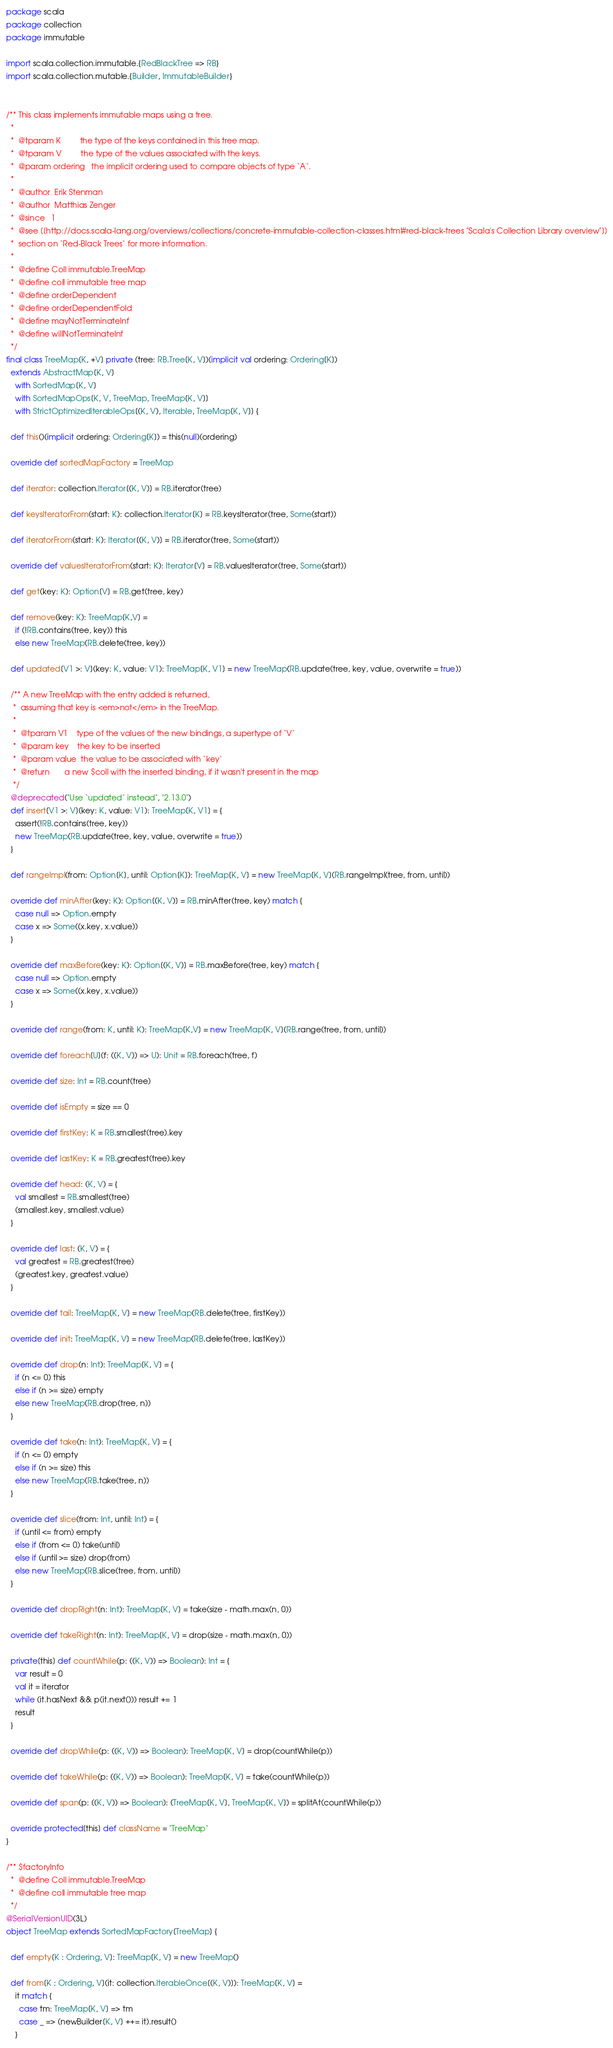<code> <loc_0><loc_0><loc_500><loc_500><_Scala_>package scala
package collection
package immutable

import scala.collection.immutable.{RedBlackTree => RB}
import scala.collection.mutable.{Builder, ImmutableBuilder}


/** This class implements immutable maps using a tree.
  *
  *  @tparam K         the type of the keys contained in this tree map.
  *  @tparam V         the type of the values associated with the keys.
  *  @param ordering   the implicit ordering used to compare objects of type `A`.
  *
  *  @author  Erik Stenman
  *  @author  Matthias Zenger
  *  @since   1
  *  @see [[http://docs.scala-lang.org/overviews/collections/concrete-immutable-collection-classes.html#red-black-trees "Scala's Collection Library overview"]]
  *  section on `Red-Black Trees` for more information.
  *
  *  @define Coll immutable.TreeMap
  *  @define coll immutable tree map
  *  @define orderDependent
  *  @define orderDependentFold
  *  @define mayNotTerminateInf
  *  @define willNotTerminateInf
  */
final class TreeMap[K, +V] private (tree: RB.Tree[K, V])(implicit val ordering: Ordering[K])
  extends AbstractMap[K, V]
    with SortedMap[K, V]
    with SortedMapOps[K, V, TreeMap, TreeMap[K, V]]
    with StrictOptimizedIterableOps[(K, V), Iterable, TreeMap[K, V]] {

  def this()(implicit ordering: Ordering[K]) = this(null)(ordering)

  override def sortedMapFactory = TreeMap

  def iterator: collection.Iterator[(K, V)] = RB.iterator(tree)

  def keysIteratorFrom(start: K): collection.Iterator[K] = RB.keysIterator(tree, Some(start))

  def iteratorFrom(start: K): Iterator[(K, V)] = RB.iterator(tree, Some(start))

  override def valuesIteratorFrom(start: K): Iterator[V] = RB.valuesIterator(tree, Some(start))

  def get(key: K): Option[V] = RB.get(tree, key)

  def remove(key: K): TreeMap[K,V] =
    if (!RB.contains(tree, key)) this
    else new TreeMap(RB.delete(tree, key))

  def updated[V1 >: V](key: K, value: V1): TreeMap[K, V1] = new TreeMap(RB.update(tree, key, value, overwrite = true))

  /** A new TreeMap with the entry added is returned,
   *  assuming that key is <em>not</em> in the TreeMap.
   *
   *  @tparam V1    type of the values of the new bindings, a supertype of `V`
   *  @param key    the key to be inserted
   *  @param value  the value to be associated with `key`
   *  @return       a new $coll with the inserted binding, if it wasn't present in the map
   */
  @deprecated("Use `updated` instead", "2.13.0")
  def insert[V1 >: V](key: K, value: V1): TreeMap[K, V1] = {
    assert(!RB.contains(tree, key))
    new TreeMap(RB.update(tree, key, value, overwrite = true))
  }

  def rangeImpl(from: Option[K], until: Option[K]): TreeMap[K, V] = new TreeMap[K, V](RB.rangeImpl(tree, from, until))

  override def minAfter(key: K): Option[(K, V)] = RB.minAfter(tree, key) match {
    case null => Option.empty
    case x => Some((x.key, x.value))
  }

  override def maxBefore(key: K): Option[(K, V)] = RB.maxBefore(tree, key) match {
    case null => Option.empty
    case x => Some((x.key, x.value))
  }

  override def range(from: K, until: K): TreeMap[K,V] = new TreeMap[K, V](RB.range(tree, from, until))

  override def foreach[U](f: ((K, V)) => U): Unit = RB.foreach(tree, f)

  override def size: Int = RB.count(tree)

  override def isEmpty = size == 0

  override def firstKey: K = RB.smallest(tree).key

  override def lastKey: K = RB.greatest(tree).key

  override def head: (K, V) = {
    val smallest = RB.smallest(tree)
    (smallest.key, smallest.value)
  }

  override def last: (K, V) = {
    val greatest = RB.greatest(tree)
    (greatest.key, greatest.value)
  }

  override def tail: TreeMap[K, V] = new TreeMap(RB.delete(tree, firstKey))

  override def init: TreeMap[K, V] = new TreeMap(RB.delete(tree, lastKey))

  override def drop(n: Int): TreeMap[K, V] = {
    if (n <= 0) this
    else if (n >= size) empty
    else new TreeMap(RB.drop(tree, n))
  }

  override def take(n: Int): TreeMap[K, V] = {
    if (n <= 0) empty
    else if (n >= size) this
    else new TreeMap(RB.take(tree, n))
  }

  override def slice(from: Int, until: Int) = {
    if (until <= from) empty
    else if (from <= 0) take(until)
    else if (until >= size) drop(from)
    else new TreeMap(RB.slice(tree, from, until))
  }

  override def dropRight(n: Int): TreeMap[K, V] = take(size - math.max(n, 0))

  override def takeRight(n: Int): TreeMap[K, V] = drop(size - math.max(n, 0))

  private[this] def countWhile(p: ((K, V)) => Boolean): Int = {
    var result = 0
    val it = iterator
    while (it.hasNext && p(it.next())) result += 1
    result
  }

  override def dropWhile(p: ((K, V)) => Boolean): TreeMap[K, V] = drop(countWhile(p))

  override def takeWhile(p: ((K, V)) => Boolean): TreeMap[K, V] = take(countWhile(p))

  override def span(p: ((K, V)) => Boolean): (TreeMap[K, V], TreeMap[K, V]) = splitAt(countWhile(p))

  override protected[this] def className = "TreeMap"
}

/** $factoryInfo
  *  @define Coll immutable.TreeMap
  *  @define coll immutable tree map
  */
@SerialVersionUID(3L)
object TreeMap extends SortedMapFactory[TreeMap] {

  def empty[K : Ordering, V]: TreeMap[K, V] = new TreeMap()

  def from[K : Ordering, V](it: collection.IterableOnce[(K, V)]): TreeMap[K, V] =
    it match {
      case tm: TreeMap[K, V] => tm
      case _ => (newBuilder[K, V] ++= it).result()
    }
</code> 